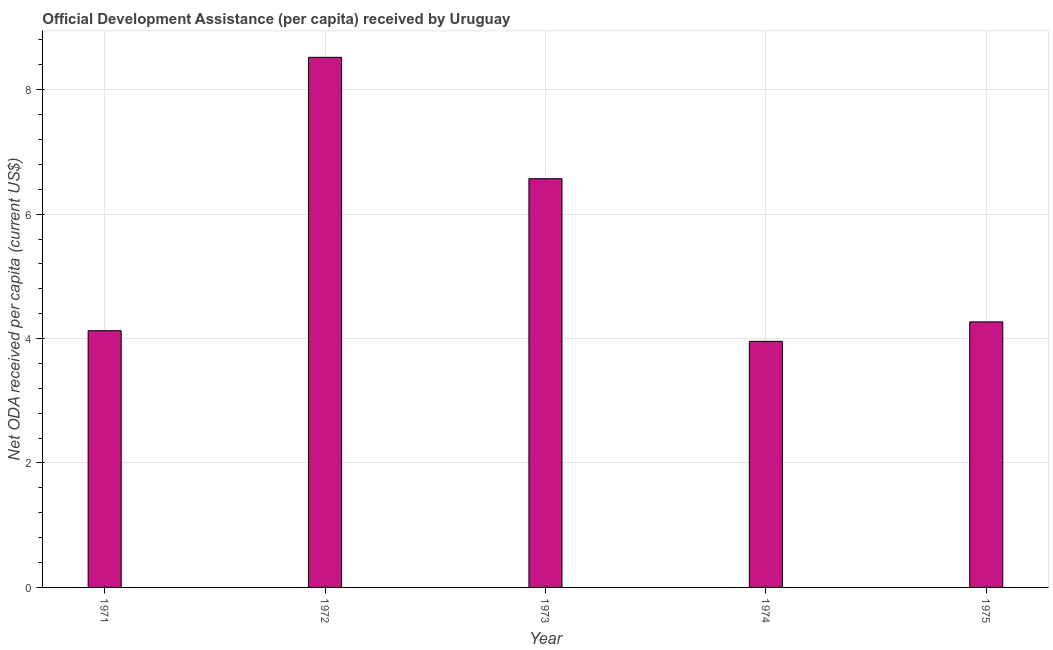Does the graph contain grids?
Your answer should be very brief. Yes. What is the title of the graph?
Ensure brevity in your answer.  Official Development Assistance (per capita) received by Uruguay. What is the label or title of the X-axis?
Your answer should be compact. Year. What is the label or title of the Y-axis?
Provide a succinct answer. Net ODA received per capita (current US$). What is the net oda received per capita in 1972?
Make the answer very short. 8.52. Across all years, what is the maximum net oda received per capita?
Your answer should be very brief. 8.52. Across all years, what is the minimum net oda received per capita?
Provide a short and direct response. 3.96. In which year was the net oda received per capita minimum?
Offer a terse response. 1974. What is the sum of the net oda received per capita?
Offer a very short reply. 27.44. What is the difference between the net oda received per capita in 1971 and 1975?
Your answer should be compact. -0.14. What is the average net oda received per capita per year?
Offer a terse response. 5.49. What is the median net oda received per capita?
Give a very brief answer. 4.27. Do a majority of the years between 1975 and 1971 (inclusive) have net oda received per capita greater than 2.4 US$?
Your answer should be very brief. Yes. What is the ratio of the net oda received per capita in 1971 to that in 1972?
Offer a very short reply. 0.48. Is the net oda received per capita in 1973 less than that in 1975?
Your response must be concise. No. What is the difference between the highest and the second highest net oda received per capita?
Provide a short and direct response. 1.95. What is the difference between the highest and the lowest net oda received per capita?
Provide a short and direct response. 4.57. In how many years, is the net oda received per capita greater than the average net oda received per capita taken over all years?
Ensure brevity in your answer.  2. Are all the bars in the graph horizontal?
Make the answer very short. No. How many years are there in the graph?
Your response must be concise. 5. What is the difference between two consecutive major ticks on the Y-axis?
Provide a succinct answer. 2. What is the Net ODA received per capita (current US$) in 1971?
Your response must be concise. 4.13. What is the Net ODA received per capita (current US$) of 1972?
Offer a very short reply. 8.52. What is the Net ODA received per capita (current US$) in 1973?
Make the answer very short. 6.57. What is the Net ODA received per capita (current US$) of 1974?
Ensure brevity in your answer.  3.96. What is the Net ODA received per capita (current US$) in 1975?
Ensure brevity in your answer.  4.27. What is the difference between the Net ODA received per capita (current US$) in 1971 and 1972?
Offer a very short reply. -4.39. What is the difference between the Net ODA received per capita (current US$) in 1971 and 1973?
Offer a very short reply. -2.44. What is the difference between the Net ODA received per capita (current US$) in 1971 and 1974?
Ensure brevity in your answer.  0.17. What is the difference between the Net ODA received per capita (current US$) in 1971 and 1975?
Keep it short and to the point. -0.14. What is the difference between the Net ODA received per capita (current US$) in 1972 and 1973?
Keep it short and to the point. 1.95. What is the difference between the Net ODA received per capita (current US$) in 1972 and 1974?
Provide a short and direct response. 4.57. What is the difference between the Net ODA received per capita (current US$) in 1972 and 1975?
Your answer should be very brief. 4.25. What is the difference between the Net ODA received per capita (current US$) in 1973 and 1974?
Offer a terse response. 2.61. What is the difference between the Net ODA received per capita (current US$) in 1973 and 1975?
Keep it short and to the point. 2.3. What is the difference between the Net ODA received per capita (current US$) in 1974 and 1975?
Offer a very short reply. -0.31. What is the ratio of the Net ODA received per capita (current US$) in 1971 to that in 1972?
Keep it short and to the point. 0.48. What is the ratio of the Net ODA received per capita (current US$) in 1971 to that in 1973?
Your answer should be compact. 0.63. What is the ratio of the Net ODA received per capita (current US$) in 1971 to that in 1974?
Make the answer very short. 1.04. What is the ratio of the Net ODA received per capita (current US$) in 1972 to that in 1973?
Your answer should be very brief. 1.3. What is the ratio of the Net ODA received per capita (current US$) in 1972 to that in 1974?
Give a very brief answer. 2.15. What is the ratio of the Net ODA received per capita (current US$) in 1972 to that in 1975?
Your answer should be very brief. 2. What is the ratio of the Net ODA received per capita (current US$) in 1973 to that in 1974?
Your response must be concise. 1.66. What is the ratio of the Net ODA received per capita (current US$) in 1973 to that in 1975?
Your response must be concise. 1.54. What is the ratio of the Net ODA received per capita (current US$) in 1974 to that in 1975?
Give a very brief answer. 0.93. 